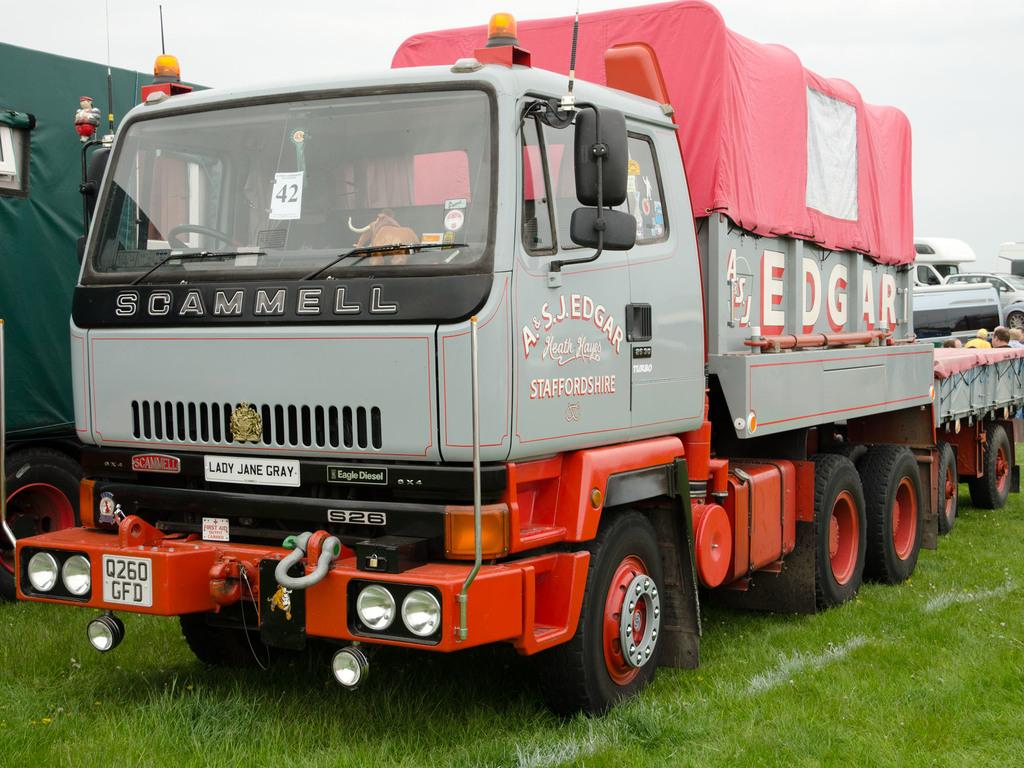What types of objects are present in the image? There are vehicles and people in the image. What is the surface at the bottom of the image made of? There is grass on the surface at the bottom of the image. What is visible at the top of the image? The sky is visible at the top of the image. Can you see anyone using a rifle in the image? There is no rifle present in the image. What order are the vehicles arranged in the image? The provided facts do not give information about the arrangement of the vehicles, so we cannot determine the order in which they are arranged. 